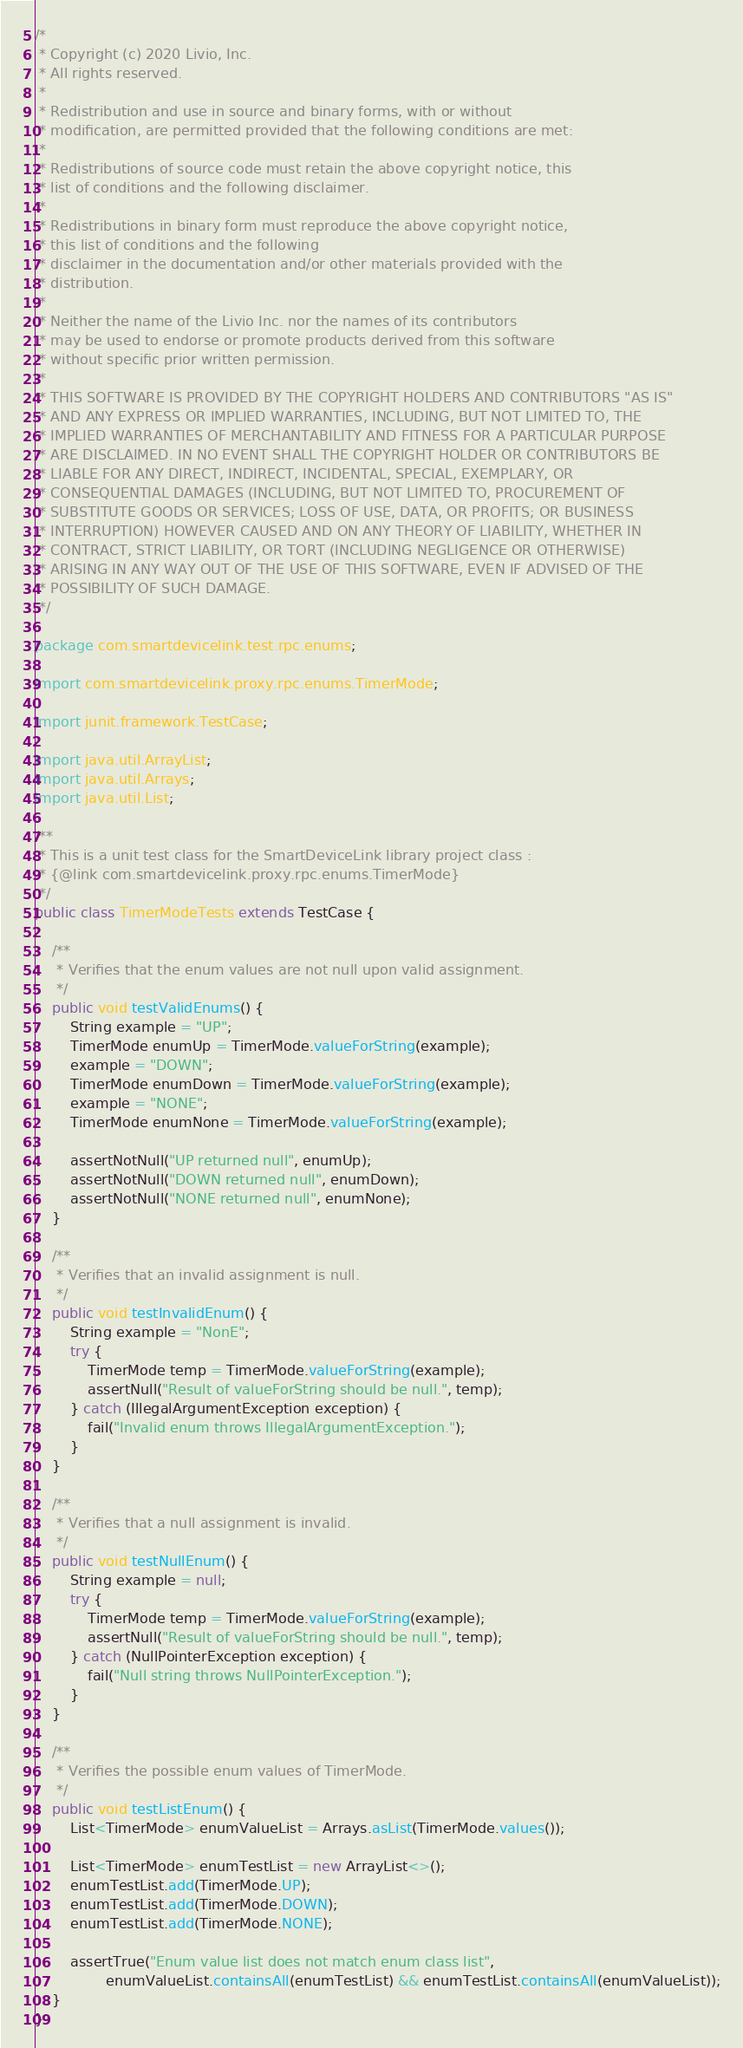Convert code to text. <code><loc_0><loc_0><loc_500><loc_500><_Java_>/*
 * Copyright (c) 2020 Livio, Inc.
 * All rights reserved.
 *
 * Redistribution and use in source and binary forms, with or without
 * modification, are permitted provided that the following conditions are met:
 *
 * Redistributions of source code must retain the above copyright notice, this
 * list of conditions and the following disclaimer.
 *
 * Redistributions in binary form must reproduce the above copyright notice,
 * this list of conditions and the following
 * disclaimer in the documentation and/or other materials provided with the
 * distribution.
 *
 * Neither the name of the Livio Inc. nor the names of its contributors
 * may be used to endorse or promote products derived from this software
 * without specific prior written permission.
 *
 * THIS SOFTWARE IS PROVIDED BY THE COPYRIGHT HOLDERS AND CONTRIBUTORS "AS IS"
 * AND ANY EXPRESS OR IMPLIED WARRANTIES, INCLUDING, BUT NOT LIMITED TO, THE
 * IMPLIED WARRANTIES OF MERCHANTABILITY AND FITNESS FOR A PARTICULAR PURPOSE
 * ARE DISCLAIMED. IN NO EVENT SHALL THE COPYRIGHT HOLDER OR CONTRIBUTORS BE
 * LIABLE FOR ANY DIRECT, INDIRECT, INCIDENTAL, SPECIAL, EXEMPLARY, OR
 * CONSEQUENTIAL DAMAGES (INCLUDING, BUT NOT LIMITED TO, PROCUREMENT OF
 * SUBSTITUTE GOODS OR SERVICES; LOSS OF USE, DATA, OR PROFITS; OR BUSINESS
 * INTERRUPTION) HOWEVER CAUSED AND ON ANY THEORY OF LIABILITY, WHETHER IN
 * CONTRACT, STRICT LIABILITY, OR TORT (INCLUDING NEGLIGENCE OR OTHERWISE)
 * ARISING IN ANY WAY OUT OF THE USE OF THIS SOFTWARE, EVEN IF ADVISED OF THE
 * POSSIBILITY OF SUCH DAMAGE.
 */

package com.smartdevicelink.test.rpc.enums;

import com.smartdevicelink.proxy.rpc.enums.TimerMode;

import junit.framework.TestCase;

import java.util.ArrayList;
import java.util.Arrays;
import java.util.List;

/**
 * This is a unit test class for the SmartDeviceLink library project class :
 * {@link com.smartdevicelink.proxy.rpc.enums.TimerMode}
 */
public class TimerModeTests extends TestCase {

    /**
     * Verifies that the enum values are not null upon valid assignment.
     */
    public void testValidEnums() {
        String example = "UP";
        TimerMode enumUp = TimerMode.valueForString(example);
        example = "DOWN";
        TimerMode enumDown = TimerMode.valueForString(example);
        example = "NONE";
        TimerMode enumNone = TimerMode.valueForString(example);

        assertNotNull("UP returned null", enumUp);
        assertNotNull("DOWN returned null", enumDown);
        assertNotNull("NONE returned null", enumNone);
    }

    /**
     * Verifies that an invalid assignment is null.
     */
    public void testInvalidEnum() {
        String example = "NonE";
        try {
            TimerMode temp = TimerMode.valueForString(example);
            assertNull("Result of valueForString should be null.", temp);
        } catch (IllegalArgumentException exception) {
            fail("Invalid enum throws IllegalArgumentException.");
        }
    }

    /**
     * Verifies that a null assignment is invalid.
     */
    public void testNullEnum() {
        String example = null;
        try {
            TimerMode temp = TimerMode.valueForString(example);
            assertNull("Result of valueForString should be null.", temp);
        } catch (NullPointerException exception) {
            fail("Null string throws NullPointerException.");
        }
    }

    /**
     * Verifies the possible enum values of TimerMode.
     */
    public void testListEnum() {
        List<TimerMode> enumValueList = Arrays.asList(TimerMode.values());

        List<TimerMode> enumTestList = new ArrayList<>();
        enumTestList.add(TimerMode.UP);
        enumTestList.add(TimerMode.DOWN);
        enumTestList.add(TimerMode.NONE);

        assertTrue("Enum value list does not match enum class list",
                enumValueList.containsAll(enumTestList) && enumTestList.containsAll(enumValueList));
    }
}</code> 